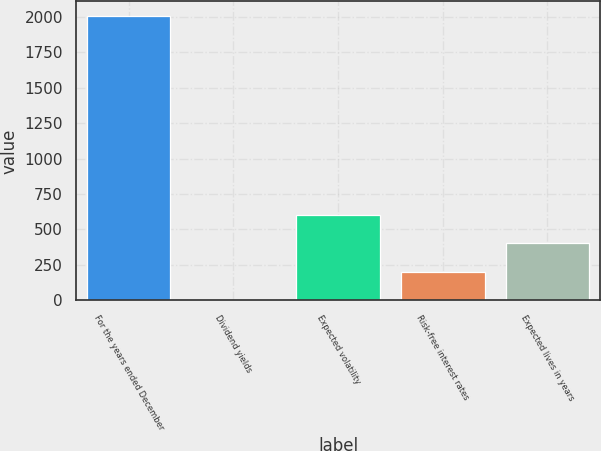Convert chart to OTSL. <chart><loc_0><loc_0><loc_500><loc_500><bar_chart><fcel>For the years ended December<fcel>Dividend yields<fcel>Expected volatility<fcel>Risk-free interest rates<fcel>Expected lives in years<nl><fcel>2007<fcel>2<fcel>603.5<fcel>202.5<fcel>403<nl></chart> 